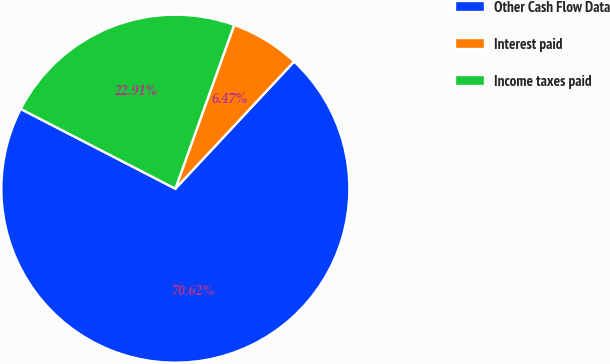<chart> <loc_0><loc_0><loc_500><loc_500><pie_chart><fcel>Other Cash Flow Data<fcel>Interest paid<fcel>Income taxes paid<nl><fcel>70.62%<fcel>6.47%<fcel>22.91%<nl></chart> 